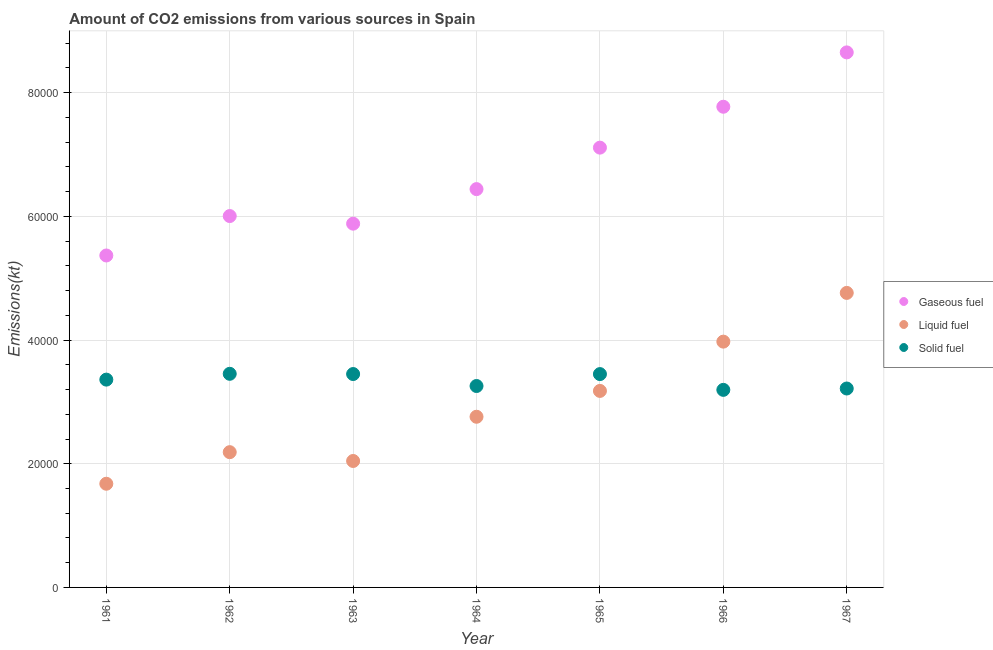How many different coloured dotlines are there?
Keep it short and to the point. 3. Is the number of dotlines equal to the number of legend labels?
Your response must be concise. Yes. What is the amount of co2 emissions from solid fuel in 1967?
Ensure brevity in your answer.  3.22e+04. Across all years, what is the maximum amount of co2 emissions from liquid fuel?
Ensure brevity in your answer.  4.76e+04. Across all years, what is the minimum amount of co2 emissions from solid fuel?
Offer a very short reply. 3.19e+04. In which year was the amount of co2 emissions from liquid fuel maximum?
Ensure brevity in your answer.  1967. What is the total amount of co2 emissions from solid fuel in the graph?
Ensure brevity in your answer.  2.34e+05. What is the difference between the amount of co2 emissions from solid fuel in 1966 and that in 1967?
Ensure brevity in your answer.  -220.02. What is the difference between the amount of co2 emissions from gaseous fuel in 1966 and the amount of co2 emissions from solid fuel in 1967?
Give a very brief answer. 4.56e+04. What is the average amount of co2 emissions from solid fuel per year?
Give a very brief answer. 3.34e+04. In the year 1961, what is the difference between the amount of co2 emissions from liquid fuel and amount of co2 emissions from solid fuel?
Make the answer very short. -1.68e+04. In how many years, is the amount of co2 emissions from solid fuel greater than 20000 kt?
Your response must be concise. 7. What is the ratio of the amount of co2 emissions from solid fuel in 1964 to that in 1966?
Your response must be concise. 1.02. Is the amount of co2 emissions from solid fuel in 1963 less than that in 1966?
Your answer should be compact. No. Is the difference between the amount of co2 emissions from liquid fuel in 1963 and 1966 greater than the difference between the amount of co2 emissions from solid fuel in 1963 and 1966?
Make the answer very short. No. What is the difference between the highest and the second highest amount of co2 emissions from gaseous fuel?
Give a very brief answer. 8789.8. What is the difference between the highest and the lowest amount of co2 emissions from liquid fuel?
Offer a terse response. 3.09e+04. Is it the case that in every year, the sum of the amount of co2 emissions from gaseous fuel and amount of co2 emissions from liquid fuel is greater than the amount of co2 emissions from solid fuel?
Ensure brevity in your answer.  Yes. Is the amount of co2 emissions from gaseous fuel strictly greater than the amount of co2 emissions from solid fuel over the years?
Your response must be concise. Yes. Is the amount of co2 emissions from solid fuel strictly less than the amount of co2 emissions from liquid fuel over the years?
Make the answer very short. No. How many dotlines are there?
Provide a succinct answer. 3. How many years are there in the graph?
Your answer should be compact. 7. Are the values on the major ticks of Y-axis written in scientific E-notation?
Your answer should be compact. No. Does the graph contain any zero values?
Make the answer very short. No. Where does the legend appear in the graph?
Offer a very short reply. Center right. How are the legend labels stacked?
Your response must be concise. Vertical. What is the title of the graph?
Provide a succinct answer. Amount of CO2 emissions from various sources in Spain. What is the label or title of the X-axis?
Offer a terse response. Year. What is the label or title of the Y-axis?
Ensure brevity in your answer.  Emissions(kt). What is the Emissions(kt) in Gaseous fuel in 1961?
Your response must be concise. 5.37e+04. What is the Emissions(kt) of Liquid fuel in 1961?
Provide a succinct answer. 1.68e+04. What is the Emissions(kt) of Solid fuel in 1961?
Offer a terse response. 3.36e+04. What is the Emissions(kt) in Gaseous fuel in 1962?
Keep it short and to the point. 6.01e+04. What is the Emissions(kt) in Liquid fuel in 1962?
Offer a very short reply. 2.19e+04. What is the Emissions(kt) of Solid fuel in 1962?
Provide a succinct answer. 3.45e+04. What is the Emissions(kt) of Gaseous fuel in 1963?
Your answer should be very brief. 5.88e+04. What is the Emissions(kt) of Liquid fuel in 1963?
Your answer should be very brief. 2.04e+04. What is the Emissions(kt) in Solid fuel in 1963?
Keep it short and to the point. 3.45e+04. What is the Emissions(kt) in Gaseous fuel in 1964?
Give a very brief answer. 6.44e+04. What is the Emissions(kt) of Liquid fuel in 1964?
Make the answer very short. 2.76e+04. What is the Emissions(kt) of Solid fuel in 1964?
Provide a short and direct response. 3.26e+04. What is the Emissions(kt) in Gaseous fuel in 1965?
Give a very brief answer. 7.11e+04. What is the Emissions(kt) of Liquid fuel in 1965?
Give a very brief answer. 3.18e+04. What is the Emissions(kt) in Solid fuel in 1965?
Your answer should be very brief. 3.45e+04. What is the Emissions(kt) in Gaseous fuel in 1966?
Offer a very short reply. 7.77e+04. What is the Emissions(kt) of Liquid fuel in 1966?
Provide a succinct answer. 3.97e+04. What is the Emissions(kt) of Solid fuel in 1966?
Make the answer very short. 3.19e+04. What is the Emissions(kt) of Gaseous fuel in 1967?
Your answer should be very brief. 8.65e+04. What is the Emissions(kt) of Liquid fuel in 1967?
Keep it short and to the point. 4.76e+04. What is the Emissions(kt) of Solid fuel in 1967?
Offer a very short reply. 3.22e+04. Across all years, what is the maximum Emissions(kt) in Gaseous fuel?
Keep it short and to the point. 8.65e+04. Across all years, what is the maximum Emissions(kt) in Liquid fuel?
Make the answer very short. 4.76e+04. Across all years, what is the maximum Emissions(kt) in Solid fuel?
Offer a terse response. 3.45e+04. Across all years, what is the minimum Emissions(kt) of Gaseous fuel?
Provide a short and direct response. 5.37e+04. Across all years, what is the minimum Emissions(kt) in Liquid fuel?
Keep it short and to the point. 1.68e+04. Across all years, what is the minimum Emissions(kt) in Solid fuel?
Your response must be concise. 3.19e+04. What is the total Emissions(kt) in Gaseous fuel in the graph?
Give a very brief answer. 4.72e+05. What is the total Emissions(kt) of Liquid fuel in the graph?
Your answer should be very brief. 2.06e+05. What is the total Emissions(kt) in Solid fuel in the graph?
Keep it short and to the point. 2.34e+05. What is the difference between the Emissions(kt) in Gaseous fuel in 1961 and that in 1962?
Make the answer very short. -6376.91. What is the difference between the Emissions(kt) of Liquid fuel in 1961 and that in 1962?
Offer a terse response. -5108.13. What is the difference between the Emissions(kt) in Solid fuel in 1961 and that in 1962?
Provide a succinct answer. -938.75. What is the difference between the Emissions(kt) in Gaseous fuel in 1961 and that in 1963?
Keep it short and to the point. -5144.8. What is the difference between the Emissions(kt) of Liquid fuel in 1961 and that in 1963?
Your answer should be compact. -3681.67. What is the difference between the Emissions(kt) of Solid fuel in 1961 and that in 1963?
Your answer should be compact. -902.08. What is the difference between the Emissions(kt) of Gaseous fuel in 1961 and that in 1964?
Give a very brief answer. -1.07e+04. What is the difference between the Emissions(kt) in Liquid fuel in 1961 and that in 1964?
Ensure brevity in your answer.  -1.08e+04. What is the difference between the Emissions(kt) in Solid fuel in 1961 and that in 1964?
Offer a terse response. 1034.09. What is the difference between the Emissions(kt) in Gaseous fuel in 1961 and that in 1965?
Offer a very short reply. -1.74e+04. What is the difference between the Emissions(kt) in Liquid fuel in 1961 and that in 1965?
Provide a succinct answer. -1.50e+04. What is the difference between the Emissions(kt) of Solid fuel in 1961 and that in 1965?
Offer a very short reply. -894.75. What is the difference between the Emissions(kt) of Gaseous fuel in 1961 and that in 1966?
Your answer should be compact. -2.41e+04. What is the difference between the Emissions(kt) in Liquid fuel in 1961 and that in 1966?
Your answer should be compact. -2.30e+04. What is the difference between the Emissions(kt) of Solid fuel in 1961 and that in 1966?
Keep it short and to the point. 1657.48. What is the difference between the Emissions(kt) in Gaseous fuel in 1961 and that in 1967?
Give a very brief answer. -3.28e+04. What is the difference between the Emissions(kt) in Liquid fuel in 1961 and that in 1967?
Your answer should be compact. -3.09e+04. What is the difference between the Emissions(kt) in Solid fuel in 1961 and that in 1967?
Keep it short and to the point. 1437.46. What is the difference between the Emissions(kt) of Gaseous fuel in 1962 and that in 1963?
Your response must be concise. 1232.11. What is the difference between the Emissions(kt) in Liquid fuel in 1962 and that in 1963?
Provide a short and direct response. 1426.46. What is the difference between the Emissions(kt) in Solid fuel in 1962 and that in 1963?
Provide a succinct answer. 36.67. What is the difference between the Emissions(kt) in Gaseous fuel in 1962 and that in 1964?
Provide a short and direct response. -4356.4. What is the difference between the Emissions(kt) in Liquid fuel in 1962 and that in 1964?
Make the answer very short. -5724.19. What is the difference between the Emissions(kt) of Solid fuel in 1962 and that in 1964?
Provide a succinct answer. 1972.85. What is the difference between the Emissions(kt) of Gaseous fuel in 1962 and that in 1965?
Make the answer very short. -1.11e+04. What is the difference between the Emissions(kt) in Liquid fuel in 1962 and that in 1965?
Your answer should be compact. -9904.57. What is the difference between the Emissions(kt) in Solid fuel in 1962 and that in 1965?
Your answer should be very brief. 44. What is the difference between the Emissions(kt) in Gaseous fuel in 1962 and that in 1966?
Give a very brief answer. -1.77e+04. What is the difference between the Emissions(kt) of Liquid fuel in 1962 and that in 1966?
Your response must be concise. -1.79e+04. What is the difference between the Emissions(kt) in Solid fuel in 1962 and that in 1966?
Give a very brief answer. 2596.24. What is the difference between the Emissions(kt) of Gaseous fuel in 1962 and that in 1967?
Keep it short and to the point. -2.65e+04. What is the difference between the Emissions(kt) of Liquid fuel in 1962 and that in 1967?
Ensure brevity in your answer.  -2.58e+04. What is the difference between the Emissions(kt) in Solid fuel in 1962 and that in 1967?
Ensure brevity in your answer.  2376.22. What is the difference between the Emissions(kt) in Gaseous fuel in 1963 and that in 1964?
Make the answer very short. -5588.51. What is the difference between the Emissions(kt) of Liquid fuel in 1963 and that in 1964?
Make the answer very short. -7150.65. What is the difference between the Emissions(kt) of Solid fuel in 1963 and that in 1964?
Your answer should be very brief. 1936.18. What is the difference between the Emissions(kt) in Gaseous fuel in 1963 and that in 1965?
Keep it short and to the point. -1.23e+04. What is the difference between the Emissions(kt) in Liquid fuel in 1963 and that in 1965?
Provide a succinct answer. -1.13e+04. What is the difference between the Emissions(kt) of Solid fuel in 1963 and that in 1965?
Provide a succinct answer. 7.33. What is the difference between the Emissions(kt) in Gaseous fuel in 1963 and that in 1966?
Your response must be concise. -1.89e+04. What is the difference between the Emissions(kt) in Liquid fuel in 1963 and that in 1966?
Your response must be concise. -1.93e+04. What is the difference between the Emissions(kt) in Solid fuel in 1963 and that in 1966?
Offer a very short reply. 2559.57. What is the difference between the Emissions(kt) of Gaseous fuel in 1963 and that in 1967?
Give a very brief answer. -2.77e+04. What is the difference between the Emissions(kt) in Liquid fuel in 1963 and that in 1967?
Provide a succinct answer. -2.72e+04. What is the difference between the Emissions(kt) in Solid fuel in 1963 and that in 1967?
Offer a very short reply. 2339.55. What is the difference between the Emissions(kt) of Gaseous fuel in 1964 and that in 1965?
Give a very brief answer. -6706.94. What is the difference between the Emissions(kt) of Liquid fuel in 1964 and that in 1965?
Give a very brief answer. -4180.38. What is the difference between the Emissions(kt) of Solid fuel in 1964 and that in 1965?
Provide a short and direct response. -1928.84. What is the difference between the Emissions(kt) in Gaseous fuel in 1964 and that in 1966?
Ensure brevity in your answer.  -1.33e+04. What is the difference between the Emissions(kt) of Liquid fuel in 1964 and that in 1966?
Offer a very short reply. -1.21e+04. What is the difference between the Emissions(kt) of Solid fuel in 1964 and that in 1966?
Ensure brevity in your answer.  623.39. What is the difference between the Emissions(kt) in Gaseous fuel in 1964 and that in 1967?
Your answer should be very brief. -2.21e+04. What is the difference between the Emissions(kt) in Liquid fuel in 1964 and that in 1967?
Ensure brevity in your answer.  -2.00e+04. What is the difference between the Emissions(kt) in Solid fuel in 1964 and that in 1967?
Offer a terse response. 403.37. What is the difference between the Emissions(kt) of Gaseous fuel in 1965 and that in 1966?
Keep it short and to the point. -6611.6. What is the difference between the Emissions(kt) of Liquid fuel in 1965 and that in 1966?
Give a very brief answer. -7968.39. What is the difference between the Emissions(kt) of Solid fuel in 1965 and that in 1966?
Ensure brevity in your answer.  2552.23. What is the difference between the Emissions(kt) in Gaseous fuel in 1965 and that in 1967?
Provide a short and direct response. -1.54e+04. What is the difference between the Emissions(kt) in Liquid fuel in 1965 and that in 1967?
Offer a very short reply. -1.58e+04. What is the difference between the Emissions(kt) in Solid fuel in 1965 and that in 1967?
Provide a short and direct response. 2332.21. What is the difference between the Emissions(kt) in Gaseous fuel in 1966 and that in 1967?
Make the answer very short. -8789.8. What is the difference between the Emissions(kt) in Liquid fuel in 1966 and that in 1967?
Ensure brevity in your answer.  -7880.38. What is the difference between the Emissions(kt) in Solid fuel in 1966 and that in 1967?
Give a very brief answer. -220.02. What is the difference between the Emissions(kt) in Gaseous fuel in 1961 and the Emissions(kt) in Liquid fuel in 1962?
Keep it short and to the point. 3.18e+04. What is the difference between the Emissions(kt) of Gaseous fuel in 1961 and the Emissions(kt) of Solid fuel in 1962?
Your answer should be compact. 1.91e+04. What is the difference between the Emissions(kt) of Liquid fuel in 1961 and the Emissions(kt) of Solid fuel in 1962?
Offer a terse response. -1.78e+04. What is the difference between the Emissions(kt) of Gaseous fuel in 1961 and the Emissions(kt) of Liquid fuel in 1963?
Ensure brevity in your answer.  3.32e+04. What is the difference between the Emissions(kt) of Gaseous fuel in 1961 and the Emissions(kt) of Solid fuel in 1963?
Offer a terse response. 1.92e+04. What is the difference between the Emissions(kt) in Liquid fuel in 1961 and the Emissions(kt) in Solid fuel in 1963?
Your answer should be compact. -1.77e+04. What is the difference between the Emissions(kt) of Gaseous fuel in 1961 and the Emissions(kt) of Liquid fuel in 1964?
Offer a terse response. 2.61e+04. What is the difference between the Emissions(kt) in Gaseous fuel in 1961 and the Emissions(kt) in Solid fuel in 1964?
Your response must be concise. 2.11e+04. What is the difference between the Emissions(kt) of Liquid fuel in 1961 and the Emissions(kt) of Solid fuel in 1964?
Provide a short and direct response. -1.58e+04. What is the difference between the Emissions(kt) in Gaseous fuel in 1961 and the Emissions(kt) in Liquid fuel in 1965?
Provide a succinct answer. 2.19e+04. What is the difference between the Emissions(kt) in Gaseous fuel in 1961 and the Emissions(kt) in Solid fuel in 1965?
Offer a terse response. 1.92e+04. What is the difference between the Emissions(kt) in Liquid fuel in 1961 and the Emissions(kt) in Solid fuel in 1965?
Provide a succinct answer. -1.77e+04. What is the difference between the Emissions(kt) in Gaseous fuel in 1961 and the Emissions(kt) in Liquid fuel in 1966?
Offer a very short reply. 1.39e+04. What is the difference between the Emissions(kt) in Gaseous fuel in 1961 and the Emissions(kt) in Solid fuel in 1966?
Your answer should be compact. 2.17e+04. What is the difference between the Emissions(kt) of Liquid fuel in 1961 and the Emissions(kt) of Solid fuel in 1966?
Provide a succinct answer. -1.52e+04. What is the difference between the Emissions(kt) of Gaseous fuel in 1961 and the Emissions(kt) of Liquid fuel in 1967?
Offer a very short reply. 6050.55. What is the difference between the Emissions(kt) in Gaseous fuel in 1961 and the Emissions(kt) in Solid fuel in 1967?
Your answer should be very brief. 2.15e+04. What is the difference between the Emissions(kt) of Liquid fuel in 1961 and the Emissions(kt) of Solid fuel in 1967?
Your answer should be compact. -1.54e+04. What is the difference between the Emissions(kt) in Gaseous fuel in 1962 and the Emissions(kt) in Liquid fuel in 1963?
Your answer should be compact. 3.96e+04. What is the difference between the Emissions(kt) of Gaseous fuel in 1962 and the Emissions(kt) of Solid fuel in 1963?
Keep it short and to the point. 2.55e+04. What is the difference between the Emissions(kt) of Liquid fuel in 1962 and the Emissions(kt) of Solid fuel in 1963?
Ensure brevity in your answer.  -1.26e+04. What is the difference between the Emissions(kt) in Gaseous fuel in 1962 and the Emissions(kt) in Liquid fuel in 1964?
Your response must be concise. 3.25e+04. What is the difference between the Emissions(kt) in Gaseous fuel in 1962 and the Emissions(kt) in Solid fuel in 1964?
Keep it short and to the point. 2.75e+04. What is the difference between the Emissions(kt) in Liquid fuel in 1962 and the Emissions(kt) in Solid fuel in 1964?
Keep it short and to the point. -1.07e+04. What is the difference between the Emissions(kt) in Gaseous fuel in 1962 and the Emissions(kt) in Liquid fuel in 1965?
Your response must be concise. 2.83e+04. What is the difference between the Emissions(kt) in Gaseous fuel in 1962 and the Emissions(kt) in Solid fuel in 1965?
Your answer should be very brief. 2.56e+04. What is the difference between the Emissions(kt) in Liquid fuel in 1962 and the Emissions(kt) in Solid fuel in 1965?
Provide a succinct answer. -1.26e+04. What is the difference between the Emissions(kt) of Gaseous fuel in 1962 and the Emissions(kt) of Liquid fuel in 1966?
Make the answer very short. 2.03e+04. What is the difference between the Emissions(kt) of Gaseous fuel in 1962 and the Emissions(kt) of Solid fuel in 1966?
Keep it short and to the point. 2.81e+04. What is the difference between the Emissions(kt) in Liquid fuel in 1962 and the Emissions(kt) in Solid fuel in 1966?
Give a very brief answer. -1.01e+04. What is the difference between the Emissions(kt) in Gaseous fuel in 1962 and the Emissions(kt) in Liquid fuel in 1967?
Make the answer very short. 1.24e+04. What is the difference between the Emissions(kt) in Gaseous fuel in 1962 and the Emissions(kt) in Solid fuel in 1967?
Your answer should be compact. 2.79e+04. What is the difference between the Emissions(kt) of Liquid fuel in 1962 and the Emissions(kt) of Solid fuel in 1967?
Your answer should be very brief. -1.03e+04. What is the difference between the Emissions(kt) of Gaseous fuel in 1963 and the Emissions(kt) of Liquid fuel in 1964?
Provide a succinct answer. 3.12e+04. What is the difference between the Emissions(kt) of Gaseous fuel in 1963 and the Emissions(kt) of Solid fuel in 1964?
Provide a short and direct response. 2.63e+04. What is the difference between the Emissions(kt) of Liquid fuel in 1963 and the Emissions(kt) of Solid fuel in 1964?
Make the answer very short. -1.21e+04. What is the difference between the Emissions(kt) of Gaseous fuel in 1963 and the Emissions(kt) of Liquid fuel in 1965?
Give a very brief answer. 2.70e+04. What is the difference between the Emissions(kt) of Gaseous fuel in 1963 and the Emissions(kt) of Solid fuel in 1965?
Give a very brief answer. 2.43e+04. What is the difference between the Emissions(kt) in Liquid fuel in 1963 and the Emissions(kt) in Solid fuel in 1965?
Your answer should be very brief. -1.41e+04. What is the difference between the Emissions(kt) of Gaseous fuel in 1963 and the Emissions(kt) of Liquid fuel in 1966?
Ensure brevity in your answer.  1.91e+04. What is the difference between the Emissions(kt) of Gaseous fuel in 1963 and the Emissions(kt) of Solid fuel in 1966?
Ensure brevity in your answer.  2.69e+04. What is the difference between the Emissions(kt) of Liquid fuel in 1963 and the Emissions(kt) of Solid fuel in 1966?
Ensure brevity in your answer.  -1.15e+04. What is the difference between the Emissions(kt) of Gaseous fuel in 1963 and the Emissions(kt) of Liquid fuel in 1967?
Offer a very short reply. 1.12e+04. What is the difference between the Emissions(kt) of Gaseous fuel in 1963 and the Emissions(kt) of Solid fuel in 1967?
Provide a short and direct response. 2.67e+04. What is the difference between the Emissions(kt) in Liquid fuel in 1963 and the Emissions(kt) in Solid fuel in 1967?
Provide a short and direct response. -1.17e+04. What is the difference between the Emissions(kt) of Gaseous fuel in 1964 and the Emissions(kt) of Liquid fuel in 1965?
Your answer should be compact. 3.26e+04. What is the difference between the Emissions(kt) in Gaseous fuel in 1964 and the Emissions(kt) in Solid fuel in 1965?
Your answer should be very brief. 2.99e+04. What is the difference between the Emissions(kt) of Liquid fuel in 1964 and the Emissions(kt) of Solid fuel in 1965?
Your response must be concise. -6901.29. What is the difference between the Emissions(kt) in Gaseous fuel in 1964 and the Emissions(kt) in Liquid fuel in 1966?
Give a very brief answer. 2.47e+04. What is the difference between the Emissions(kt) in Gaseous fuel in 1964 and the Emissions(kt) in Solid fuel in 1966?
Offer a very short reply. 3.25e+04. What is the difference between the Emissions(kt) in Liquid fuel in 1964 and the Emissions(kt) in Solid fuel in 1966?
Your response must be concise. -4349.06. What is the difference between the Emissions(kt) of Gaseous fuel in 1964 and the Emissions(kt) of Liquid fuel in 1967?
Your answer should be very brief. 1.68e+04. What is the difference between the Emissions(kt) of Gaseous fuel in 1964 and the Emissions(kt) of Solid fuel in 1967?
Offer a very short reply. 3.22e+04. What is the difference between the Emissions(kt) of Liquid fuel in 1964 and the Emissions(kt) of Solid fuel in 1967?
Your answer should be very brief. -4569.08. What is the difference between the Emissions(kt) in Gaseous fuel in 1965 and the Emissions(kt) in Liquid fuel in 1966?
Give a very brief answer. 3.14e+04. What is the difference between the Emissions(kt) of Gaseous fuel in 1965 and the Emissions(kt) of Solid fuel in 1966?
Offer a very short reply. 3.92e+04. What is the difference between the Emissions(kt) in Liquid fuel in 1965 and the Emissions(kt) in Solid fuel in 1966?
Your answer should be very brief. -168.68. What is the difference between the Emissions(kt) in Gaseous fuel in 1965 and the Emissions(kt) in Liquid fuel in 1967?
Your answer should be compact. 2.35e+04. What is the difference between the Emissions(kt) in Gaseous fuel in 1965 and the Emissions(kt) in Solid fuel in 1967?
Your answer should be very brief. 3.90e+04. What is the difference between the Emissions(kt) of Liquid fuel in 1965 and the Emissions(kt) of Solid fuel in 1967?
Provide a succinct answer. -388.7. What is the difference between the Emissions(kt) in Gaseous fuel in 1966 and the Emissions(kt) in Liquid fuel in 1967?
Provide a succinct answer. 3.01e+04. What is the difference between the Emissions(kt) in Gaseous fuel in 1966 and the Emissions(kt) in Solid fuel in 1967?
Keep it short and to the point. 4.56e+04. What is the difference between the Emissions(kt) in Liquid fuel in 1966 and the Emissions(kt) in Solid fuel in 1967?
Ensure brevity in your answer.  7579.69. What is the average Emissions(kt) of Gaseous fuel per year?
Give a very brief answer. 6.75e+04. What is the average Emissions(kt) in Liquid fuel per year?
Provide a succinct answer. 2.94e+04. What is the average Emissions(kt) in Solid fuel per year?
Make the answer very short. 3.34e+04. In the year 1961, what is the difference between the Emissions(kt) of Gaseous fuel and Emissions(kt) of Liquid fuel?
Your answer should be compact. 3.69e+04. In the year 1961, what is the difference between the Emissions(kt) in Gaseous fuel and Emissions(kt) in Solid fuel?
Ensure brevity in your answer.  2.01e+04. In the year 1961, what is the difference between the Emissions(kt) in Liquid fuel and Emissions(kt) in Solid fuel?
Offer a terse response. -1.68e+04. In the year 1962, what is the difference between the Emissions(kt) in Gaseous fuel and Emissions(kt) in Liquid fuel?
Your response must be concise. 3.82e+04. In the year 1962, what is the difference between the Emissions(kt) in Gaseous fuel and Emissions(kt) in Solid fuel?
Offer a very short reply. 2.55e+04. In the year 1962, what is the difference between the Emissions(kt) of Liquid fuel and Emissions(kt) of Solid fuel?
Your response must be concise. -1.27e+04. In the year 1963, what is the difference between the Emissions(kt) of Gaseous fuel and Emissions(kt) of Liquid fuel?
Keep it short and to the point. 3.84e+04. In the year 1963, what is the difference between the Emissions(kt) in Gaseous fuel and Emissions(kt) in Solid fuel?
Offer a terse response. 2.43e+04. In the year 1963, what is the difference between the Emissions(kt) of Liquid fuel and Emissions(kt) of Solid fuel?
Provide a short and direct response. -1.41e+04. In the year 1964, what is the difference between the Emissions(kt) in Gaseous fuel and Emissions(kt) in Liquid fuel?
Your answer should be compact. 3.68e+04. In the year 1964, what is the difference between the Emissions(kt) in Gaseous fuel and Emissions(kt) in Solid fuel?
Your response must be concise. 3.18e+04. In the year 1964, what is the difference between the Emissions(kt) in Liquid fuel and Emissions(kt) in Solid fuel?
Provide a succinct answer. -4972.45. In the year 1965, what is the difference between the Emissions(kt) in Gaseous fuel and Emissions(kt) in Liquid fuel?
Your answer should be very brief. 3.93e+04. In the year 1965, what is the difference between the Emissions(kt) of Gaseous fuel and Emissions(kt) of Solid fuel?
Make the answer very short. 3.66e+04. In the year 1965, what is the difference between the Emissions(kt) in Liquid fuel and Emissions(kt) in Solid fuel?
Your answer should be compact. -2720.91. In the year 1966, what is the difference between the Emissions(kt) in Gaseous fuel and Emissions(kt) in Liquid fuel?
Ensure brevity in your answer.  3.80e+04. In the year 1966, what is the difference between the Emissions(kt) of Gaseous fuel and Emissions(kt) of Solid fuel?
Your answer should be very brief. 4.58e+04. In the year 1966, what is the difference between the Emissions(kt) of Liquid fuel and Emissions(kt) of Solid fuel?
Offer a terse response. 7799.71. In the year 1967, what is the difference between the Emissions(kt) of Gaseous fuel and Emissions(kt) of Liquid fuel?
Ensure brevity in your answer.  3.89e+04. In the year 1967, what is the difference between the Emissions(kt) of Gaseous fuel and Emissions(kt) of Solid fuel?
Your answer should be compact. 5.44e+04. In the year 1967, what is the difference between the Emissions(kt) of Liquid fuel and Emissions(kt) of Solid fuel?
Your answer should be compact. 1.55e+04. What is the ratio of the Emissions(kt) of Gaseous fuel in 1961 to that in 1962?
Your answer should be very brief. 0.89. What is the ratio of the Emissions(kt) in Liquid fuel in 1961 to that in 1962?
Make the answer very short. 0.77. What is the ratio of the Emissions(kt) of Solid fuel in 1961 to that in 1962?
Offer a very short reply. 0.97. What is the ratio of the Emissions(kt) in Gaseous fuel in 1961 to that in 1963?
Offer a very short reply. 0.91. What is the ratio of the Emissions(kt) in Liquid fuel in 1961 to that in 1963?
Ensure brevity in your answer.  0.82. What is the ratio of the Emissions(kt) of Solid fuel in 1961 to that in 1963?
Offer a terse response. 0.97. What is the ratio of the Emissions(kt) of Gaseous fuel in 1961 to that in 1964?
Give a very brief answer. 0.83. What is the ratio of the Emissions(kt) of Liquid fuel in 1961 to that in 1964?
Make the answer very short. 0.61. What is the ratio of the Emissions(kt) in Solid fuel in 1961 to that in 1964?
Your answer should be very brief. 1.03. What is the ratio of the Emissions(kt) in Gaseous fuel in 1961 to that in 1965?
Offer a very short reply. 0.75. What is the ratio of the Emissions(kt) in Liquid fuel in 1961 to that in 1965?
Offer a very short reply. 0.53. What is the ratio of the Emissions(kt) in Solid fuel in 1961 to that in 1965?
Provide a short and direct response. 0.97. What is the ratio of the Emissions(kt) in Gaseous fuel in 1961 to that in 1966?
Ensure brevity in your answer.  0.69. What is the ratio of the Emissions(kt) of Liquid fuel in 1961 to that in 1966?
Give a very brief answer. 0.42. What is the ratio of the Emissions(kt) of Solid fuel in 1961 to that in 1966?
Give a very brief answer. 1.05. What is the ratio of the Emissions(kt) of Gaseous fuel in 1961 to that in 1967?
Provide a succinct answer. 0.62. What is the ratio of the Emissions(kt) of Liquid fuel in 1961 to that in 1967?
Provide a short and direct response. 0.35. What is the ratio of the Emissions(kt) in Solid fuel in 1961 to that in 1967?
Provide a succinct answer. 1.04. What is the ratio of the Emissions(kt) of Gaseous fuel in 1962 to that in 1963?
Make the answer very short. 1.02. What is the ratio of the Emissions(kt) of Liquid fuel in 1962 to that in 1963?
Give a very brief answer. 1.07. What is the ratio of the Emissions(kt) of Gaseous fuel in 1962 to that in 1964?
Your answer should be very brief. 0.93. What is the ratio of the Emissions(kt) in Liquid fuel in 1962 to that in 1964?
Your response must be concise. 0.79. What is the ratio of the Emissions(kt) in Solid fuel in 1962 to that in 1964?
Your response must be concise. 1.06. What is the ratio of the Emissions(kt) of Gaseous fuel in 1962 to that in 1965?
Your response must be concise. 0.84. What is the ratio of the Emissions(kt) of Liquid fuel in 1962 to that in 1965?
Your answer should be compact. 0.69. What is the ratio of the Emissions(kt) in Solid fuel in 1962 to that in 1965?
Keep it short and to the point. 1. What is the ratio of the Emissions(kt) of Gaseous fuel in 1962 to that in 1966?
Your answer should be very brief. 0.77. What is the ratio of the Emissions(kt) in Liquid fuel in 1962 to that in 1966?
Give a very brief answer. 0.55. What is the ratio of the Emissions(kt) of Solid fuel in 1962 to that in 1966?
Offer a terse response. 1.08. What is the ratio of the Emissions(kt) in Gaseous fuel in 1962 to that in 1967?
Provide a short and direct response. 0.69. What is the ratio of the Emissions(kt) of Liquid fuel in 1962 to that in 1967?
Give a very brief answer. 0.46. What is the ratio of the Emissions(kt) in Solid fuel in 1962 to that in 1967?
Offer a very short reply. 1.07. What is the ratio of the Emissions(kt) in Gaseous fuel in 1963 to that in 1964?
Your answer should be very brief. 0.91. What is the ratio of the Emissions(kt) of Liquid fuel in 1963 to that in 1964?
Provide a short and direct response. 0.74. What is the ratio of the Emissions(kt) of Solid fuel in 1963 to that in 1964?
Your answer should be compact. 1.06. What is the ratio of the Emissions(kt) in Gaseous fuel in 1963 to that in 1965?
Your answer should be compact. 0.83. What is the ratio of the Emissions(kt) in Liquid fuel in 1963 to that in 1965?
Ensure brevity in your answer.  0.64. What is the ratio of the Emissions(kt) in Gaseous fuel in 1963 to that in 1966?
Keep it short and to the point. 0.76. What is the ratio of the Emissions(kt) in Liquid fuel in 1963 to that in 1966?
Provide a succinct answer. 0.51. What is the ratio of the Emissions(kt) in Solid fuel in 1963 to that in 1966?
Offer a terse response. 1.08. What is the ratio of the Emissions(kt) of Gaseous fuel in 1963 to that in 1967?
Provide a short and direct response. 0.68. What is the ratio of the Emissions(kt) in Liquid fuel in 1963 to that in 1967?
Make the answer very short. 0.43. What is the ratio of the Emissions(kt) of Solid fuel in 1963 to that in 1967?
Make the answer very short. 1.07. What is the ratio of the Emissions(kt) in Gaseous fuel in 1964 to that in 1965?
Provide a succinct answer. 0.91. What is the ratio of the Emissions(kt) of Liquid fuel in 1964 to that in 1965?
Give a very brief answer. 0.87. What is the ratio of the Emissions(kt) in Solid fuel in 1964 to that in 1965?
Make the answer very short. 0.94. What is the ratio of the Emissions(kt) of Gaseous fuel in 1964 to that in 1966?
Offer a very short reply. 0.83. What is the ratio of the Emissions(kt) of Liquid fuel in 1964 to that in 1966?
Ensure brevity in your answer.  0.69. What is the ratio of the Emissions(kt) of Solid fuel in 1964 to that in 1966?
Your response must be concise. 1.02. What is the ratio of the Emissions(kt) of Gaseous fuel in 1964 to that in 1967?
Ensure brevity in your answer.  0.74. What is the ratio of the Emissions(kt) in Liquid fuel in 1964 to that in 1967?
Your response must be concise. 0.58. What is the ratio of the Emissions(kt) of Solid fuel in 1964 to that in 1967?
Keep it short and to the point. 1.01. What is the ratio of the Emissions(kt) in Gaseous fuel in 1965 to that in 1966?
Your response must be concise. 0.91. What is the ratio of the Emissions(kt) of Liquid fuel in 1965 to that in 1966?
Your answer should be compact. 0.8. What is the ratio of the Emissions(kt) of Solid fuel in 1965 to that in 1966?
Your response must be concise. 1.08. What is the ratio of the Emissions(kt) in Gaseous fuel in 1965 to that in 1967?
Offer a very short reply. 0.82. What is the ratio of the Emissions(kt) of Liquid fuel in 1965 to that in 1967?
Provide a succinct answer. 0.67. What is the ratio of the Emissions(kt) of Solid fuel in 1965 to that in 1967?
Keep it short and to the point. 1.07. What is the ratio of the Emissions(kt) of Gaseous fuel in 1966 to that in 1967?
Provide a succinct answer. 0.9. What is the ratio of the Emissions(kt) in Liquid fuel in 1966 to that in 1967?
Give a very brief answer. 0.83. What is the difference between the highest and the second highest Emissions(kt) of Gaseous fuel?
Provide a succinct answer. 8789.8. What is the difference between the highest and the second highest Emissions(kt) of Liquid fuel?
Your answer should be very brief. 7880.38. What is the difference between the highest and the second highest Emissions(kt) in Solid fuel?
Provide a short and direct response. 36.67. What is the difference between the highest and the lowest Emissions(kt) of Gaseous fuel?
Keep it short and to the point. 3.28e+04. What is the difference between the highest and the lowest Emissions(kt) in Liquid fuel?
Your answer should be compact. 3.09e+04. What is the difference between the highest and the lowest Emissions(kt) of Solid fuel?
Give a very brief answer. 2596.24. 